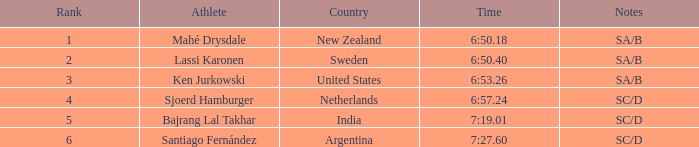What is the top position for the team that achieved a time of 6:5 2.0. 